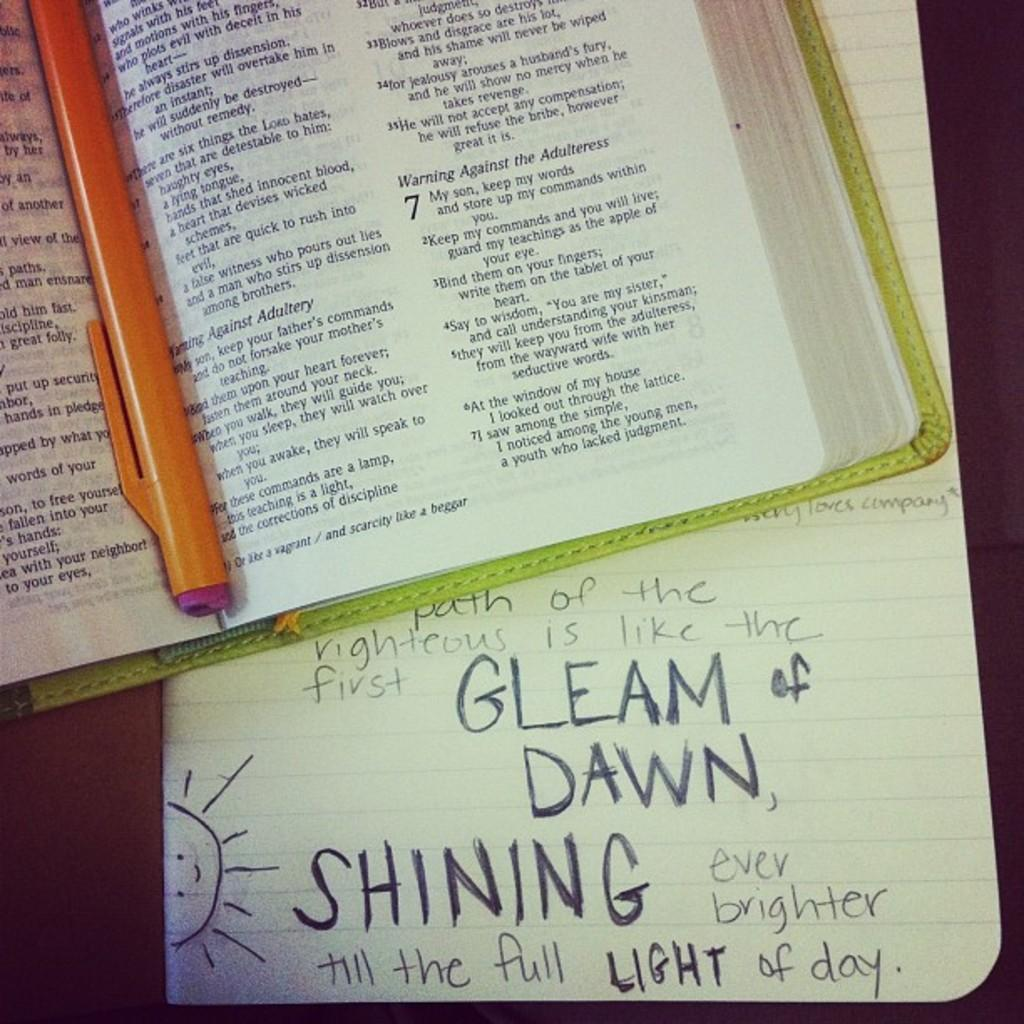<image>
Write a terse but informative summary of the picture. A book open with a piece of paper under it that states "Gleam of Dawn". 